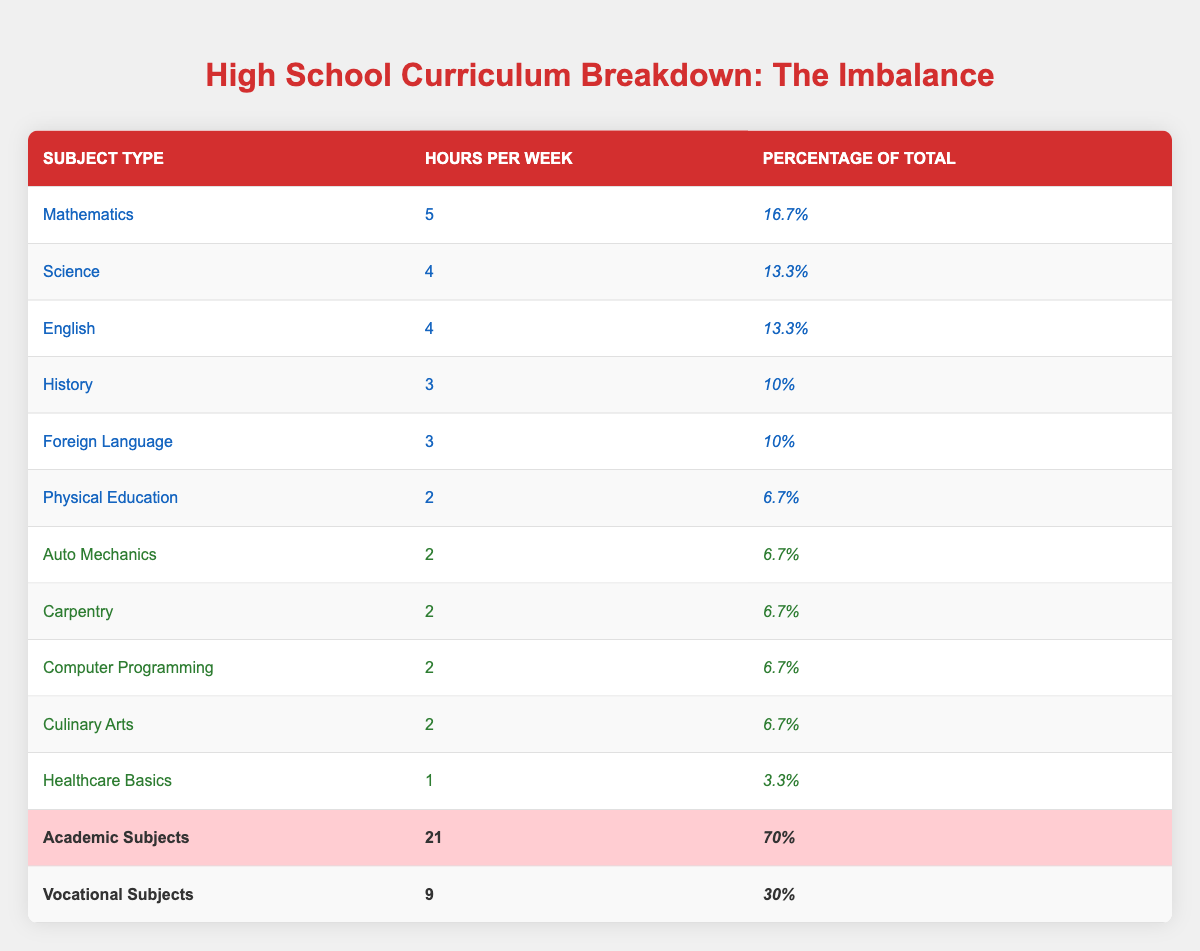What percentage of the curriculum is dedicated to academic subjects? The table shows that academic subjects have a total of 21 hours per week, which is 70% of the total curriculum. Therefore, the percentage dedicated to academic subjects is clearly stated as 70%.
Answer: 70% How many hours are respectively allocated for Auto Mechanics and Culinary Arts? The table indicates that Auto Mechanics has 2 hours per week and Culinary Arts also has 2 hours per week. Therefore, the allocation for both subjects is equal.
Answer: 2 hours each What is the combined total of hours per week for vocational subjects? The vocational subjects listed are Auto Mechanics, Carpentry, Computer Programming, Culinary Arts, and Healthcare Basics, which have 2, 2, 2, 2, and 1 hour respectively. Adding these up: 2 + 2 + 2 + 2 + 1 = 9 hours per week. Hence, the total hours allocated for vocational subjects is 9.
Answer: 9 Is Healthcare Basics allocated more time than Foreign Language? Foreign Language is allocated 3 hours per week, while Healthcare Basics is allocated only 1 hour per week. Thus, it is false that Healthcare Basics has more time allocated to it than Foreign Language.
Answer: No What is the difference in hours dedicated to academic subjects and vocational subjects? Academic subjects total 21 hours while vocational subjects total 9 hours. The difference is calculated by subtracting the vocational hours from the academic hours: 21 - 9 = 12 hours. This indicates that academic subjects receive 12 more hours than vocational ones.
Answer: 12 hours Which academic subject has the highest number of hours per week? The table lists Mathematics as having 5 hours per week, which is higher than any other academic subject's allocation. The other subjects like Science and English each have 4 hours. Therefore, Mathematics is the subject with the highest hours.
Answer: Mathematics Are there more academic subjects contributing to the curriculum than vocational subjects? The table shows 6 academic subjects (Mathematics, Science, English, History, Foreign Language, and Physical Education) versus 5 vocational subjects (Auto Mechanics, Carpentry, Computer Programming, Culinary Arts, and Healthcare Basics). Thus, it is true that there are more academic subjects than vocational subjects.
Answer: Yes What percentage of the total curriculum does Physical Education make up? Physical Education has 2 hours per week, and this represents 6.7% of the total curriculum as stated in the table. Therefore, the percentage of the curriculum dedicated to Physical Education is already provided.
Answer: 6.7% 